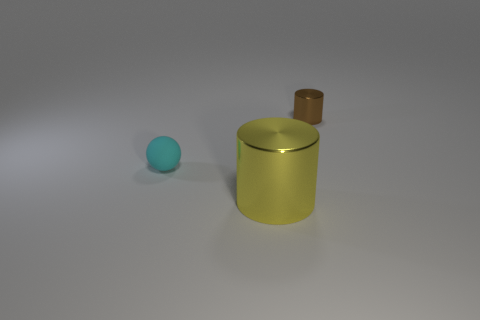Subtract 2 cylinders. How many cylinders are left? 0 Subtract all brown cylinders. How many cylinders are left? 1 Subtract all cylinders. How many objects are left? 1 Subtract all objects. Subtract all large cyan things. How many objects are left? 0 Add 1 matte things. How many matte things are left? 2 Add 3 tiny objects. How many tiny objects exist? 5 Add 3 tiny metal things. How many objects exist? 6 Subtract 0 red spheres. How many objects are left? 3 Subtract all purple cylinders. Subtract all blue spheres. How many cylinders are left? 2 Subtract all yellow balls. How many brown cylinders are left? 1 